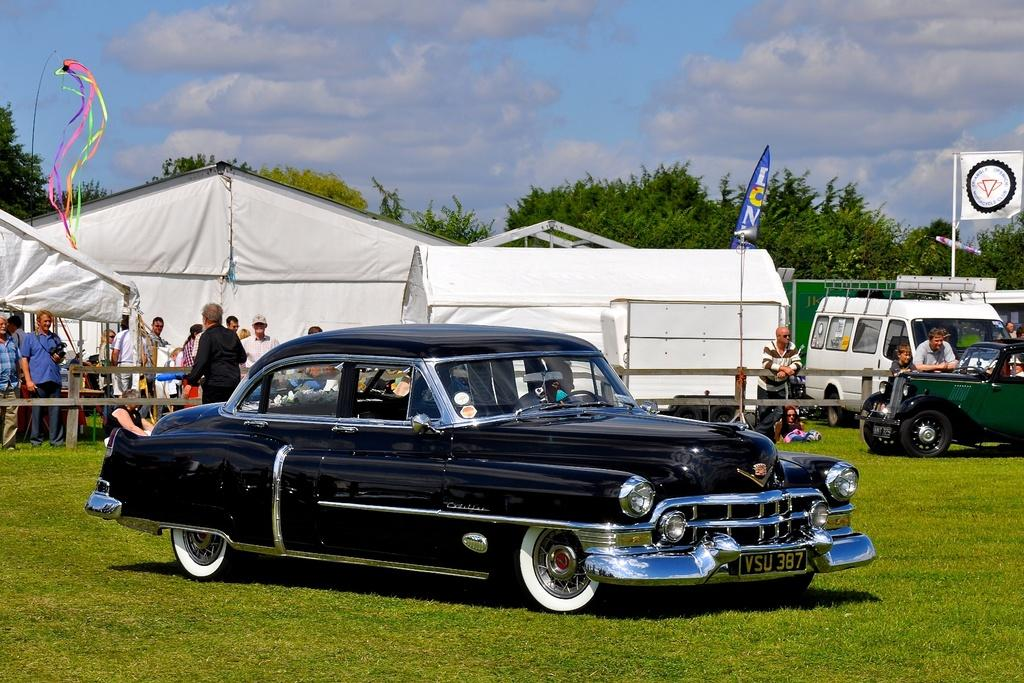What is located on the grass in the image? There are vehicles on the grass in the image. Who or what can be seen in the image besides the vehicles? There are people and tents in the image. What is visible in the background of the image? There are trees and clouds in the sky in the background of the image. How many brushes are being used by the people in the image? There is no mention of brushes in the image, so it is impossible to determine how many are being used. What type of bit is being consumed by the people in the image? There is no mention of any food or drink resembling a bit in the image. 